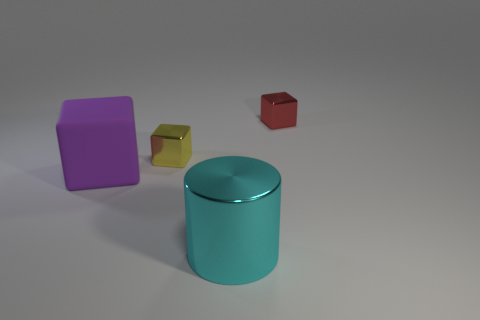What material is the small object that is right of the metal cube left of the cyan thing made of?
Your response must be concise. Metal. The other cube that is the same material as the small yellow block is what color?
Ensure brevity in your answer.  Red. There is a metallic block that is left of the small red thing; is its size the same as the thing that is in front of the large rubber thing?
Offer a very short reply. No. How many cubes are either yellow objects or brown rubber objects?
Provide a succinct answer. 1. Do the big object in front of the large purple thing and the tiny yellow block have the same material?
Give a very brief answer. Yes. What number of other things are there of the same size as the yellow block?
Provide a short and direct response. 1. How many large things are purple matte things or red objects?
Provide a short and direct response. 1. Do the rubber thing and the cylinder have the same color?
Give a very brief answer. No. Is the number of cyan shiny things that are to the left of the small yellow thing greater than the number of large rubber cubes in front of the big purple object?
Your answer should be compact. No. There is a block right of the big shiny object; is its color the same as the rubber cube?
Give a very brief answer. No. 